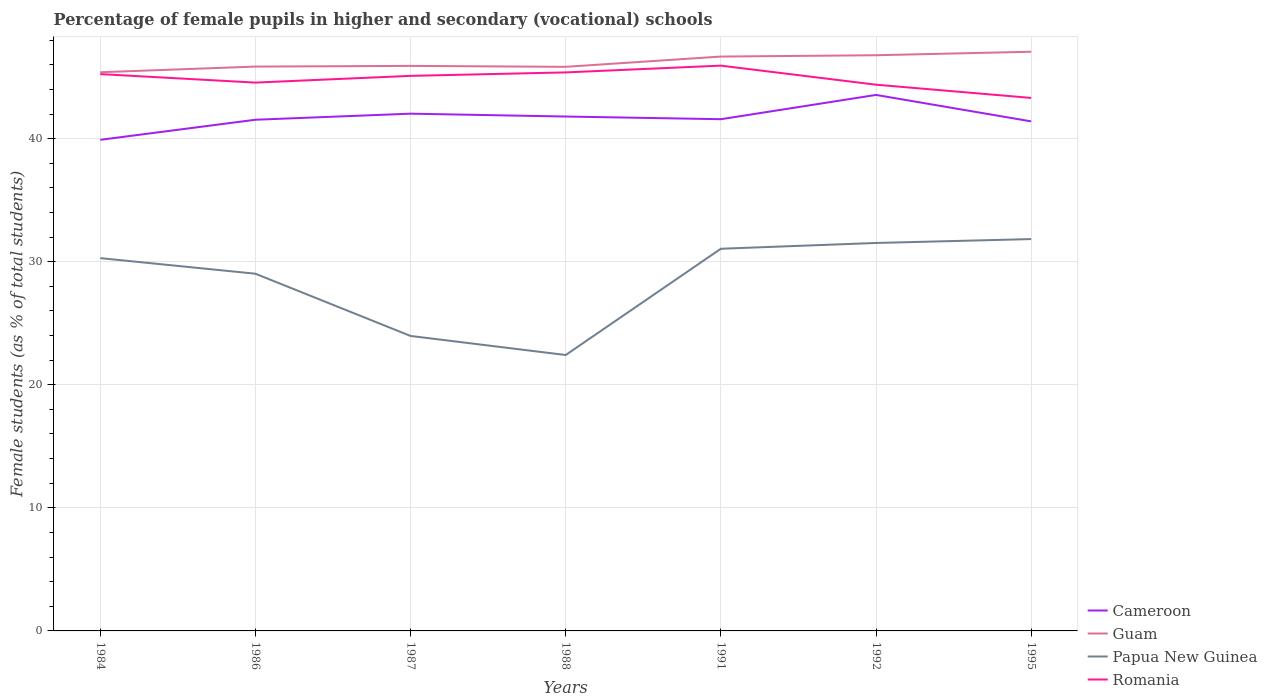Is the number of lines equal to the number of legend labels?
Provide a short and direct response. Yes. Across all years, what is the maximum percentage of female pupils in higher and secondary schools in Cameroon?
Ensure brevity in your answer.  39.9. In which year was the percentage of female pupils in higher and secondary schools in Guam maximum?
Your answer should be compact. 1984. What is the total percentage of female pupils in higher and secondary schools in Cameroon in the graph?
Make the answer very short. -1.67. What is the difference between the highest and the second highest percentage of female pupils in higher and secondary schools in Guam?
Your response must be concise. 1.67. What is the difference between the highest and the lowest percentage of female pupils in higher and secondary schools in Romania?
Keep it short and to the point. 4. Is the percentage of female pupils in higher and secondary schools in Romania strictly greater than the percentage of female pupils in higher and secondary schools in Guam over the years?
Offer a very short reply. Yes. What is the difference between two consecutive major ticks on the Y-axis?
Give a very brief answer. 10. Where does the legend appear in the graph?
Offer a very short reply. Bottom right. How many legend labels are there?
Keep it short and to the point. 4. How are the legend labels stacked?
Provide a succinct answer. Vertical. What is the title of the graph?
Keep it short and to the point. Percentage of female pupils in higher and secondary (vocational) schools. What is the label or title of the X-axis?
Make the answer very short. Years. What is the label or title of the Y-axis?
Make the answer very short. Female students (as % of total students). What is the Female students (as % of total students) of Cameroon in 1984?
Provide a succinct answer. 39.9. What is the Female students (as % of total students) in Guam in 1984?
Give a very brief answer. 45.39. What is the Female students (as % of total students) of Papua New Guinea in 1984?
Ensure brevity in your answer.  30.29. What is the Female students (as % of total students) of Romania in 1984?
Make the answer very short. 45.24. What is the Female students (as % of total students) of Cameroon in 1986?
Your response must be concise. 41.53. What is the Female students (as % of total students) in Guam in 1986?
Ensure brevity in your answer.  45.85. What is the Female students (as % of total students) in Papua New Guinea in 1986?
Offer a very short reply. 29.02. What is the Female students (as % of total students) in Romania in 1986?
Your response must be concise. 44.55. What is the Female students (as % of total students) in Cameroon in 1987?
Ensure brevity in your answer.  42.03. What is the Female students (as % of total students) in Guam in 1987?
Give a very brief answer. 45.91. What is the Female students (as % of total students) in Papua New Guinea in 1987?
Ensure brevity in your answer.  23.97. What is the Female students (as % of total students) of Romania in 1987?
Keep it short and to the point. 45.1. What is the Female students (as % of total students) in Cameroon in 1988?
Provide a succinct answer. 41.79. What is the Female students (as % of total students) in Guam in 1988?
Keep it short and to the point. 45.83. What is the Female students (as % of total students) of Papua New Guinea in 1988?
Offer a very short reply. 22.42. What is the Female students (as % of total students) in Romania in 1988?
Provide a short and direct response. 45.38. What is the Female students (as % of total students) of Cameroon in 1991?
Give a very brief answer. 41.58. What is the Female students (as % of total students) of Guam in 1991?
Keep it short and to the point. 46.67. What is the Female students (as % of total students) in Papua New Guinea in 1991?
Your answer should be very brief. 31.05. What is the Female students (as % of total students) in Romania in 1991?
Give a very brief answer. 45.93. What is the Female students (as % of total students) in Cameroon in 1992?
Offer a very short reply. 43.55. What is the Female students (as % of total students) in Guam in 1992?
Keep it short and to the point. 46.77. What is the Female students (as % of total students) in Papua New Guinea in 1992?
Give a very brief answer. 31.52. What is the Female students (as % of total students) of Romania in 1992?
Your answer should be very brief. 44.38. What is the Female students (as % of total students) in Cameroon in 1995?
Provide a succinct answer. 41.4. What is the Female students (as % of total students) of Guam in 1995?
Offer a terse response. 47.06. What is the Female students (as % of total students) of Papua New Guinea in 1995?
Offer a terse response. 31.84. What is the Female students (as % of total students) of Romania in 1995?
Offer a terse response. 43.31. Across all years, what is the maximum Female students (as % of total students) in Cameroon?
Your response must be concise. 43.55. Across all years, what is the maximum Female students (as % of total students) of Guam?
Offer a terse response. 47.06. Across all years, what is the maximum Female students (as % of total students) in Papua New Guinea?
Provide a succinct answer. 31.84. Across all years, what is the maximum Female students (as % of total students) of Romania?
Ensure brevity in your answer.  45.93. Across all years, what is the minimum Female students (as % of total students) of Cameroon?
Offer a terse response. 39.9. Across all years, what is the minimum Female students (as % of total students) in Guam?
Provide a succinct answer. 45.39. Across all years, what is the minimum Female students (as % of total students) of Papua New Guinea?
Your answer should be compact. 22.42. Across all years, what is the minimum Female students (as % of total students) in Romania?
Give a very brief answer. 43.31. What is the total Female students (as % of total students) in Cameroon in the graph?
Provide a short and direct response. 291.79. What is the total Female students (as % of total students) of Guam in the graph?
Provide a short and direct response. 323.49. What is the total Female students (as % of total students) in Papua New Guinea in the graph?
Offer a very short reply. 200.11. What is the total Female students (as % of total students) of Romania in the graph?
Keep it short and to the point. 313.89. What is the difference between the Female students (as % of total students) of Cameroon in 1984 and that in 1986?
Ensure brevity in your answer.  -1.63. What is the difference between the Female students (as % of total students) of Guam in 1984 and that in 1986?
Give a very brief answer. -0.46. What is the difference between the Female students (as % of total students) of Papua New Guinea in 1984 and that in 1986?
Provide a succinct answer. 1.27. What is the difference between the Female students (as % of total students) of Romania in 1984 and that in 1986?
Provide a succinct answer. 0.69. What is the difference between the Female students (as % of total students) of Cameroon in 1984 and that in 1987?
Your response must be concise. -2.12. What is the difference between the Female students (as % of total students) of Guam in 1984 and that in 1987?
Provide a short and direct response. -0.52. What is the difference between the Female students (as % of total students) of Papua New Guinea in 1984 and that in 1987?
Provide a short and direct response. 6.32. What is the difference between the Female students (as % of total students) in Romania in 1984 and that in 1987?
Ensure brevity in your answer.  0.14. What is the difference between the Female students (as % of total students) in Cameroon in 1984 and that in 1988?
Make the answer very short. -1.89. What is the difference between the Female students (as % of total students) of Guam in 1984 and that in 1988?
Give a very brief answer. -0.44. What is the difference between the Female students (as % of total students) of Papua New Guinea in 1984 and that in 1988?
Your answer should be compact. 7.87. What is the difference between the Female students (as % of total students) in Romania in 1984 and that in 1988?
Make the answer very short. -0.14. What is the difference between the Female students (as % of total students) of Cameroon in 1984 and that in 1991?
Your answer should be compact. -1.67. What is the difference between the Female students (as % of total students) of Guam in 1984 and that in 1991?
Offer a very short reply. -1.27. What is the difference between the Female students (as % of total students) in Papua New Guinea in 1984 and that in 1991?
Give a very brief answer. -0.76. What is the difference between the Female students (as % of total students) of Romania in 1984 and that in 1991?
Provide a short and direct response. -0.69. What is the difference between the Female students (as % of total students) of Cameroon in 1984 and that in 1992?
Ensure brevity in your answer.  -3.65. What is the difference between the Female students (as % of total students) of Guam in 1984 and that in 1992?
Offer a very short reply. -1.38. What is the difference between the Female students (as % of total students) of Papua New Guinea in 1984 and that in 1992?
Keep it short and to the point. -1.23. What is the difference between the Female students (as % of total students) in Romania in 1984 and that in 1992?
Your answer should be compact. 0.86. What is the difference between the Female students (as % of total students) of Cameroon in 1984 and that in 1995?
Provide a short and direct response. -1.5. What is the difference between the Female students (as % of total students) in Guam in 1984 and that in 1995?
Give a very brief answer. -1.67. What is the difference between the Female students (as % of total students) in Papua New Guinea in 1984 and that in 1995?
Give a very brief answer. -1.55. What is the difference between the Female students (as % of total students) in Romania in 1984 and that in 1995?
Provide a succinct answer. 1.94. What is the difference between the Female students (as % of total students) of Cameroon in 1986 and that in 1987?
Provide a short and direct response. -0.49. What is the difference between the Female students (as % of total students) of Guam in 1986 and that in 1987?
Your response must be concise. -0.06. What is the difference between the Female students (as % of total students) in Papua New Guinea in 1986 and that in 1987?
Your answer should be very brief. 5.06. What is the difference between the Female students (as % of total students) of Romania in 1986 and that in 1987?
Make the answer very short. -0.55. What is the difference between the Female students (as % of total students) of Cameroon in 1986 and that in 1988?
Make the answer very short. -0.26. What is the difference between the Female students (as % of total students) of Guam in 1986 and that in 1988?
Provide a short and direct response. 0.02. What is the difference between the Female students (as % of total students) in Papua New Guinea in 1986 and that in 1988?
Your answer should be very brief. 6.6. What is the difference between the Female students (as % of total students) in Romania in 1986 and that in 1988?
Your answer should be compact. -0.83. What is the difference between the Female students (as % of total students) in Cameroon in 1986 and that in 1991?
Keep it short and to the point. -0.04. What is the difference between the Female students (as % of total students) of Guam in 1986 and that in 1991?
Make the answer very short. -0.81. What is the difference between the Female students (as % of total students) in Papua New Guinea in 1986 and that in 1991?
Ensure brevity in your answer.  -2.03. What is the difference between the Female students (as % of total students) in Romania in 1986 and that in 1991?
Offer a terse response. -1.38. What is the difference between the Female students (as % of total students) in Cameroon in 1986 and that in 1992?
Make the answer very short. -2.02. What is the difference between the Female students (as % of total students) in Guam in 1986 and that in 1992?
Your response must be concise. -0.92. What is the difference between the Female students (as % of total students) of Papua New Guinea in 1986 and that in 1992?
Provide a succinct answer. -2.5. What is the difference between the Female students (as % of total students) in Romania in 1986 and that in 1992?
Your answer should be compact. 0.17. What is the difference between the Female students (as % of total students) in Cameroon in 1986 and that in 1995?
Ensure brevity in your answer.  0.13. What is the difference between the Female students (as % of total students) in Guam in 1986 and that in 1995?
Provide a short and direct response. -1.21. What is the difference between the Female students (as % of total students) of Papua New Guinea in 1986 and that in 1995?
Give a very brief answer. -2.81. What is the difference between the Female students (as % of total students) in Romania in 1986 and that in 1995?
Offer a very short reply. 1.25. What is the difference between the Female students (as % of total students) of Cameroon in 1987 and that in 1988?
Provide a succinct answer. 0.23. What is the difference between the Female students (as % of total students) in Guam in 1987 and that in 1988?
Keep it short and to the point. 0.08. What is the difference between the Female students (as % of total students) of Papua New Guinea in 1987 and that in 1988?
Ensure brevity in your answer.  1.55. What is the difference between the Female students (as % of total students) in Romania in 1987 and that in 1988?
Provide a short and direct response. -0.28. What is the difference between the Female students (as % of total students) in Cameroon in 1987 and that in 1991?
Provide a succinct answer. 0.45. What is the difference between the Female students (as % of total students) of Guam in 1987 and that in 1991?
Offer a terse response. -0.76. What is the difference between the Female students (as % of total students) in Papua New Guinea in 1987 and that in 1991?
Provide a succinct answer. -7.09. What is the difference between the Female students (as % of total students) in Romania in 1987 and that in 1991?
Make the answer very short. -0.83. What is the difference between the Female students (as % of total students) in Cameroon in 1987 and that in 1992?
Offer a terse response. -1.52. What is the difference between the Female students (as % of total students) in Guam in 1987 and that in 1992?
Your answer should be compact. -0.87. What is the difference between the Female students (as % of total students) of Papua New Guinea in 1987 and that in 1992?
Make the answer very short. -7.56. What is the difference between the Female students (as % of total students) in Romania in 1987 and that in 1992?
Offer a very short reply. 0.72. What is the difference between the Female students (as % of total students) in Cameroon in 1987 and that in 1995?
Provide a succinct answer. 0.63. What is the difference between the Female students (as % of total students) in Guam in 1987 and that in 1995?
Your answer should be compact. -1.15. What is the difference between the Female students (as % of total students) of Papua New Guinea in 1987 and that in 1995?
Offer a terse response. -7.87. What is the difference between the Female students (as % of total students) in Romania in 1987 and that in 1995?
Give a very brief answer. 1.79. What is the difference between the Female students (as % of total students) of Cameroon in 1988 and that in 1991?
Provide a succinct answer. 0.22. What is the difference between the Female students (as % of total students) of Papua New Guinea in 1988 and that in 1991?
Your answer should be compact. -8.63. What is the difference between the Female students (as % of total students) in Romania in 1988 and that in 1991?
Provide a succinct answer. -0.55. What is the difference between the Female students (as % of total students) of Cameroon in 1988 and that in 1992?
Keep it short and to the point. -1.76. What is the difference between the Female students (as % of total students) in Guam in 1988 and that in 1992?
Provide a succinct answer. -0.94. What is the difference between the Female students (as % of total students) of Papua New Guinea in 1988 and that in 1992?
Make the answer very short. -9.1. What is the difference between the Female students (as % of total students) in Romania in 1988 and that in 1992?
Provide a short and direct response. 1. What is the difference between the Female students (as % of total students) in Cameroon in 1988 and that in 1995?
Provide a succinct answer. 0.39. What is the difference between the Female students (as % of total students) of Guam in 1988 and that in 1995?
Provide a succinct answer. -1.23. What is the difference between the Female students (as % of total students) in Papua New Guinea in 1988 and that in 1995?
Ensure brevity in your answer.  -9.42. What is the difference between the Female students (as % of total students) of Romania in 1988 and that in 1995?
Your answer should be very brief. 2.07. What is the difference between the Female students (as % of total students) in Cameroon in 1991 and that in 1992?
Provide a succinct answer. -1.97. What is the difference between the Female students (as % of total students) of Guam in 1991 and that in 1992?
Offer a terse response. -0.11. What is the difference between the Female students (as % of total students) of Papua New Guinea in 1991 and that in 1992?
Offer a terse response. -0.47. What is the difference between the Female students (as % of total students) in Romania in 1991 and that in 1992?
Your answer should be compact. 1.55. What is the difference between the Female students (as % of total students) of Cameroon in 1991 and that in 1995?
Offer a terse response. 0.18. What is the difference between the Female students (as % of total students) in Guam in 1991 and that in 1995?
Your response must be concise. -0.39. What is the difference between the Female students (as % of total students) in Papua New Guinea in 1991 and that in 1995?
Offer a very short reply. -0.79. What is the difference between the Female students (as % of total students) in Romania in 1991 and that in 1995?
Keep it short and to the point. 2.62. What is the difference between the Female students (as % of total students) in Cameroon in 1992 and that in 1995?
Offer a very short reply. 2.15. What is the difference between the Female students (as % of total students) in Guam in 1992 and that in 1995?
Give a very brief answer. -0.28. What is the difference between the Female students (as % of total students) in Papua New Guinea in 1992 and that in 1995?
Ensure brevity in your answer.  -0.32. What is the difference between the Female students (as % of total students) in Romania in 1992 and that in 1995?
Give a very brief answer. 1.08. What is the difference between the Female students (as % of total students) in Cameroon in 1984 and the Female students (as % of total students) in Guam in 1986?
Ensure brevity in your answer.  -5.95. What is the difference between the Female students (as % of total students) of Cameroon in 1984 and the Female students (as % of total students) of Papua New Guinea in 1986?
Provide a short and direct response. 10.88. What is the difference between the Female students (as % of total students) of Cameroon in 1984 and the Female students (as % of total students) of Romania in 1986?
Offer a very short reply. -4.65. What is the difference between the Female students (as % of total students) of Guam in 1984 and the Female students (as % of total students) of Papua New Guinea in 1986?
Make the answer very short. 16.37. What is the difference between the Female students (as % of total students) of Guam in 1984 and the Female students (as % of total students) of Romania in 1986?
Offer a terse response. 0.84. What is the difference between the Female students (as % of total students) in Papua New Guinea in 1984 and the Female students (as % of total students) in Romania in 1986?
Offer a very short reply. -14.26. What is the difference between the Female students (as % of total students) of Cameroon in 1984 and the Female students (as % of total students) of Guam in 1987?
Your answer should be very brief. -6.01. What is the difference between the Female students (as % of total students) of Cameroon in 1984 and the Female students (as % of total students) of Papua New Guinea in 1987?
Offer a terse response. 15.94. What is the difference between the Female students (as % of total students) of Cameroon in 1984 and the Female students (as % of total students) of Romania in 1987?
Ensure brevity in your answer.  -5.2. What is the difference between the Female students (as % of total students) in Guam in 1984 and the Female students (as % of total students) in Papua New Guinea in 1987?
Your answer should be compact. 21.43. What is the difference between the Female students (as % of total students) of Guam in 1984 and the Female students (as % of total students) of Romania in 1987?
Ensure brevity in your answer.  0.29. What is the difference between the Female students (as % of total students) in Papua New Guinea in 1984 and the Female students (as % of total students) in Romania in 1987?
Make the answer very short. -14.81. What is the difference between the Female students (as % of total students) in Cameroon in 1984 and the Female students (as % of total students) in Guam in 1988?
Ensure brevity in your answer.  -5.93. What is the difference between the Female students (as % of total students) of Cameroon in 1984 and the Female students (as % of total students) of Papua New Guinea in 1988?
Keep it short and to the point. 17.48. What is the difference between the Female students (as % of total students) of Cameroon in 1984 and the Female students (as % of total students) of Romania in 1988?
Make the answer very short. -5.48. What is the difference between the Female students (as % of total students) of Guam in 1984 and the Female students (as % of total students) of Papua New Guinea in 1988?
Your response must be concise. 22.97. What is the difference between the Female students (as % of total students) in Guam in 1984 and the Female students (as % of total students) in Romania in 1988?
Keep it short and to the point. 0.01. What is the difference between the Female students (as % of total students) of Papua New Guinea in 1984 and the Female students (as % of total students) of Romania in 1988?
Offer a terse response. -15.09. What is the difference between the Female students (as % of total students) of Cameroon in 1984 and the Female students (as % of total students) of Guam in 1991?
Offer a very short reply. -6.76. What is the difference between the Female students (as % of total students) of Cameroon in 1984 and the Female students (as % of total students) of Papua New Guinea in 1991?
Make the answer very short. 8.85. What is the difference between the Female students (as % of total students) of Cameroon in 1984 and the Female students (as % of total students) of Romania in 1991?
Give a very brief answer. -6.03. What is the difference between the Female students (as % of total students) of Guam in 1984 and the Female students (as % of total students) of Papua New Guinea in 1991?
Your answer should be compact. 14.34. What is the difference between the Female students (as % of total students) of Guam in 1984 and the Female students (as % of total students) of Romania in 1991?
Your answer should be compact. -0.54. What is the difference between the Female students (as % of total students) in Papua New Guinea in 1984 and the Female students (as % of total students) in Romania in 1991?
Make the answer very short. -15.64. What is the difference between the Female students (as % of total students) of Cameroon in 1984 and the Female students (as % of total students) of Guam in 1992?
Your answer should be very brief. -6.87. What is the difference between the Female students (as % of total students) of Cameroon in 1984 and the Female students (as % of total students) of Papua New Guinea in 1992?
Offer a very short reply. 8.38. What is the difference between the Female students (as % of total students) in Cameroon in 1984 and the Female students (as % of total students) in Romania in 1992?
Ensure brevity in your answer.  -4.48. What is the difference between the Female students (as % of total students) of Guam in 1984 and the Female students (as % of total students) of Papua New Guinea in 1992?
Give a very brief answer. 13.87. What is the difference between the Female students (as % of total students) of Guam in 1984 and the Female students (as % of total students) of Romania in 1992?
Your response must be concise. 1.01. What is the difference between the Female students (as % of total students) of Papua New Guinea in 1984 and the Female students (as % of total students) of Romania in 1992?
Your answer should be very brief. -14.09. What is the difference between the Female students (as % of total students) in Cameroon in 1984 and the Female students (as % of total students) in Guam in 1995?
Ensure brevity in your answer.  -7.16. What is the difference between the Female students (as % of total students) of Cameroon in 1984 and the Female students (as % of total students) of Papua New Guinea in 1995?
Your answer should be compact. 8.06. What is the difference between the Female students (as % of total students) of Cameroon in 1984 and the Female students (as % of total students) of Romania in 1995?
Keep it short and to the point. -3.4. What is the difference between the Female students (as % of total students) of Guam in 1984 and the Female students (as % of total students) of Papua New Guinea in 1995?
Provide a short and direct response. 13.55. What is the difference between the Female students (as % of total students) in Guam in 1984 and the Female students (as % of total students) in Romania in 1995?
Ensure brevity in your answer.  2.09. What is the difference between the Female students (as % of total students) in Papua New Guinea in 1984 and the Female students (as % of total students) in Romania in 1995?
Provide a succinct answer. -13.02. What is the difference between the Female students (as % of total students) in Cameroon in 1986 and the Female students (as % of total students) in Guam in 1987?
Your response must be concise. -4.38. What is the difference between the Female students (as % of total students) in Cameroon in 1986 and the Female students (as % of total students) in Papua New Guinea in 1987?
Your answer should be very brief. 17.57. What is the difference between the Female students (as % of total students) of Cameroon in 1986 and the Female students (as % of total students) of Romania in 1987?
Keep it short and to the point. -3.57. What is the difference between the Female students (as % of total students) in Guam in 1986 and the Female students (as % of total students) in Papua New Guinea in 1987?
Provide a succinct answer. 21.89. What is the difference between the Female students (as % of total students) in Guam in 1986 and the Female students (as % of total students) in Romania in 1987?
Give a very brief answer. 0.76. What is the difference between the Female students (as % of total students) in Papua New Guinea in 1986 and the Female students (as % of total students) in Romania in 1987?
Provide a short and direct response. -16.08. What is the difference between the Female students (as % of total students) of Cameroon in 1986 and the Female students (as % of total students) of Guam in 1988?
Offer a terse response. -4.3. What is the difference between the Female students (as % of total students) in Cameroon in 1986 and the Female students (as % of total students) in Papua New Guinea in 1988?
Your answer should be very brief. 19.12. What is the difference between the Female students (as % of total students) of Cameroon in 1986 and the Female students (as % of total students) of Romania in 1988?
Give a very brief answer. -3.85. What is the difference between the Female students (as % of total students) of Guam in 1986 and the Female students (as % of total students) of Papua New Guinea in 1988?
Keep it short and to the point. 23.44. What is the difference between the Female students (as % of total students) in Guam in 1986 and the Female students (as % of total students) in Romania in 1988?
Make the answer very short. 0.47. What is the difference between the Female students (as % of total students) in Papua New Guinea in 1986 and the Female students (as % of total students) in Romania in 1988?
Your answer should be very brief. -16.36. What is the difference between the Female students (as % of total students) in Cameroon in 1986 and the Female students (as % of total students) in Guam in 1991?
Give a very brief answer. -5.13. What is the difference between the Female students (as % of total students) in Cameroon in 1986 and the Female students (as % of total students) in Papua New Guinea in 1991?
Provide a short and direct response. 10.48. What is the difference between the Female students (as % of total students) in Cameroon in 1986 and the Female students (as % of total students) in Romania in 1991?
Make the answer very short. -4.4. What is the difference between the Female students (as % of total students) in Guam in 1986 and the Female students (as % of total students) in Papua New Guinea in 1991?
Offer a very short reply. 14.8. What is the difference between the Female students (as % of total students) in Guam in 1986 and the Female students (as % of total students) in Romania in 1991?
Offer a terse response. -0.08. What is the difference between the Female students (as % of total students) in Papua New Guinea in 1986 and the Female students (as % of total students) in Romania in 1991?
Your answer should be compact. -16.91. What is the difference between the Female students (as % of total students) of Cameroon in 1986 and the Female students (as % of total students) of Guam in 1992?
Offer a terse response. -5.24. What is the difference between the Female students (as % of total students) of Cameroon in 1986 and the Female students (as % of total students) of Papua New Guinea in 1992?
Provide a short and direct response. 10.01. What is the difference between the Female students (as % of total students) in Cameroon in 1986 and the Female students (as % of total students) in Romania in 1992?
Ensure brevity in your answer.  -2.85. What is the difference between the Female students (as % of total students) in Guam in 1986 and the Female students (as % of total students) in Papua New Guinea in 1992?
Offer a terse response. 14.33. What is the difference between the Female students (as % of total students) of Guam in 1986 and the Female students (as % of total students) of Romania in 1992?
Keep it short and to the point. 1.47. What is the difference between the Female students (as % of total students) in Papua New Guinea in 1986 and the Female students (as % of total students) in Romania in 1992?
Your response must be concise. -15.36. What is the difference between the Female students (as % of total students) of Cameroon in 1986 and the Female students (as % of total students) of Guam in 1995?
Ensure brevity in your answer.  -5.53. What is the difference between the Female students (as % of total students) in Cameroon in 1986 and the Female students (as % of total students) in Papua New Guinea in 1995?
Your response must be concise. 9.7. What is the difference between the Female students (as % of total students) in Cameroon in 1986 and the Female students (as % of total students) in Romania in 1995?
Ensure brevity in your answer.  -1.77. What is the difference between the Female students (as % of total students) of Guam in 1986 and the Female students (as % of total students) of Papua New Guinea in 1995?
Provide a short and direct response. 14.02. What is the difference between the Female students (as % of total students) of Guam in 1986 and the Female students (as % of total students) of Romania in 1995?
Your answer should be compact. 2.55. What is the difference between the Female students (as % of total students) of Papua New Guinea in 1986 and the Female students (as % of total students) of Romania in 1995?
Give a very brief answer. -14.28. What is the difference between the Female students (as % of total students) in Cameroon in 1987 and the Female students (as % of total students) in Guam in 1988?
Offer a very short reply. -3.81. What is the difference between the Female students (as % of total students) of Cameroon in 1987 and the Female students (as % of total students) of Papua New Guinea in 1988?
Offer a very short reply. 19.61. What is the difference between the Female students (as % of total students) of Cameroon in 1987 and the Female students (as % of total students) of Romania in 1988?
Your answer should be very brief. -3.35. What is the difference between the Female students (as % of total students) in Guam in 1987 and the Female students (as % of total students) in Papua New Guinea in 1988?
Provide a succinct answer. 23.49. What is the difference between the Female students (as % of total students) in Guam in 1987 and the Female students (as % of total students) in Romania in 1988?
Your answer should be very brief. 0.53. What is the difference between the Female students (as % of total students) in Papua New Guinea in 1987 and the Female students (as % of total students) in Romania in 1988?
Offer a very short reply. -21.41. What is the difference between the Female students (as % of total students) in Cameroon in 1987 and the Female students (as % of total students) in Guam in 1991?
Keep it short and to the point. -4.64. What is the difference between the Female students (as % of total students) in Cameroon in 1987 and the Female students (as % of total students) in Papua New Guinea in 1991?
Offer a terse response. 10.97. What is the difference between the Female students (as % of total students) in Cameroon in 1987 and the Female students (as % of total students) in Romania in 1991?
Provide a short and direct response. -3.9. What is the difference between the Female students (as % of total students) in Guam in 1987 and the Female students (as % of total students) in Papua New Guinea in 1991?
Ensure brevity in your answer.  14.86. What is the difference between the Female students (as % of total students) of Guam in 1987 and the Female students (as % of total students) of Romania in 1991?
Offer a terse response. -0.02. What is the difference between the Female students (as % of total students) of Papua New Guinea in 1987 and the Female students (as % of total students) of Romania in 1991?
Ensure brevity in your answer.  -21.96. What is the difference between the Female students (as % of total students) in Cameroon in 1987 and the Female students (as % of total students) in Guam in 1992?
Make the answer very short. -4.75. What is the difference between the Female students (as % of total students) of Cameroon in 1987 and the Female students (as % of total students) of Papua New Guinea in 1992?
Provide a succinct answer. 10.51. What is the difference between the Female students (as % of total students) in Cameroon in 1987 and the Female students (as % of total students) in Romania in 1992?
Ensure brevity in your answer.  -2.35. What is the difference between the Female students (as % of total students) of Guam in 1987 and the Female students (as % of total students) of Papua New Guinea in 1992?
Your answer should be very brief. 14.39. What is the difference between the Female students (as % of total students) of Guam in 1987 and the Female students (as % of total students) of Romania in 1992?
Offer a terse response. 1.53. What is the difference between the Female students (as % of total students) of Papua New Guinea in 1987 and the Female students (as % of total students) of Romania in 1992?
Ensure brevity in your answer.  -20.42. What is the difference between the Female students (as % of total students) of Cameroon in 1987 and the Female students (as % of total students) of Guam in 1995?
Your answer should be compact. -5.03. What is the difference between the Female students (as % of total students) of Cameroon in 1987 and the Female students (as % of total students) of Papua New Guinea in 1995?
Keep it short and to the point. 10.19. What is the difference between the Female students (as % of total students) of Cameroon in 1987 and the Female students (as % of total students) of Romania in 1995?
Offer a terse response. -1.28. What is the difference between the Female students (as % of total students) in Guam in 1987 and the Female students (as % of total students) in Papua New Guinea in 1995?
Give a very brief answer. 14.07. What is the difference between the Female students (as % of total students) of Guam in 1987 and the Female students (as % of total students) of Romania in 1995?
Your response must be concise. 2.6. What is the difference between the Female students (as % of total students) of Papua New Guinea in 1987 and the Female students (as % of total students) of Romania in 1995?
Your response must be concise. -19.34. What is the difference between the Female students (as % of total students) of Cameroon in 1988 and the Female students (as % of total students) of Guam in 1991?
Provide a short and direct response. -4.87. What is the difference between the Female students (as % of total students) in Cameroon in 1988 and the Female students (as % of total students) in Papua New Guinea in 1991?
Ensure brevity in your answer.  10.74. What is the difference between the Female students (as % of total students) in Cameroon in 1988 and the Female students (as % of total students) in Romania in 1991?
Your answer should be compact. -4.14. What is the difference between the Female students (as % of total students) in Guam in 1988 and the Female students (as % of total students) in Papua New Guinea in 1991?
Provide a succinct answer. 14.78. What is the difference between the Female students (as % of total students) in Guam in 1988 and the Female students (as % of total students) in Romania in 1991?
Offer a terse response. -0.1. What is the difference between the Female students (as % of total students) in Papua New Guinea in 1988 and the Female students (as % of total students) in Romania in 1991?
Keep it short and to the point. -23.51. What is the difference between the Female students (as % of total students) in Cameroon in 1988 and the Female students (as % of total students) in Guam in 1992?
Give a very brief answer. -4.98. What is the difference between the Female students (as % of total students) in Cameroon in 1988 and the Female students (as % of total students) in Papua New Guinea in 1992?
Offer a very short reply. 10.27. What is the difference between the Female students (as % of total students) of Cameroon in 1988 and the Female students (as % of total students) of Romania in 1992?
Provide a succinct answer. -2.59. What is the difference between the Female students (as % of total students) in Guam in 1988 and the Female students (as % of total students) in Papua New Guinea in 1992?
Your response must be concise. 14.31. What is the difference between the Female students (as % of total students) of Guam in 1988 and the Female students (as % of total students) of Romania in 1992?
Ensure brevity in your answer.  1.45. What is the difference between the Female students (as % of total students) in Papua New Guinea in 1988 and the Female students (as % of total students) in Romania in 1992?
Make the answer very short. -21.96. What is the difference between the Female students (as % of total students) of Cameroon in 1988 and the Female students (as % of total students) of Guam in 1995?
Your answer should be compact. -5.26. What is the difference between the Female students (as % of total students) in Cameroon in 1988 and the Female students (as % of total students) in Papua New Guinea in 1995?
Provide a succinct answer. 9.96. What is the difference between the Female students (as % of total students) of Cameroon in 1988 and the Female students (as % of total students) of Romania in 1995?
Ensure brevity in your answer.  -1.51. What is the difference between the Female students (as % of total students) in Guam in 1988 and the Female students (as % of total students) in Papua New Guinea in 1995?
Offer a very short reply. 14. What is the difference between the Female students (as % of total students) of Guam in 1988 and the Female students (as % of total students) of Romania in 1995?
Provide a short and direct response. 2.53. What is the difference between the Female students (as % of total students) in Papua New Guinea in 1988 and the Female students (as % of total students) in Romania in 1995?
Offer a very short reply. -20.89. What is the difference between the Female students (as % of total students) in Cameroon in 1991 and the Female students (as % of total students) in Guam in 1992?
Your response must be concise. -5.2. What is the difference between the Female students (as % of total students) of Cameroon in 1991 and the Female students (as % of total students) of Papua New Guinea in 1992?
Your answer should be very brief. 10.06. What is the difference between the Female students (as % of total students) in Cameroon in 1991 and the Female students (as % of total students) in Romania in 1992?
Provide a succinct answer. -2.8. What is the difference between the Female students (as % of total students) in Guam in 1991 and the Female students (as % of total students) in Papua New Guinea in 1992?
Ensure brevity in your answer.  15.15. What is the difference between the Female students (as % of total students) in Guam in 1991 and the Female students (as % of total students) in Romania in 1992?
Provide a short and direct response. 2.29. What is the difference between the Female students (as % of total students) of Papua New Guinea in 1991 and the Female students (as % of total students) of Romania in 1992?
Keep it short and to the point. -13.33. What is the difference between the Female students (as % of total students) of Cameroon in 1991 and the Female students (as % of total students) of Guam in 1995?
Ensure brevity in your answer.  -5.48. What is the difference between the Female students (as % of total students) in Cameroon in 1991 and the Female students (as % of total students) in Papua New Guinea in 1995?
Your answer should be compact. 9.74. What is the difference between the Female students (as % of total students) in Cameroon in 1991 and the Female students (as % of total students) in Romania in 1995?
Provide a short and direct response. -1.73. What is the difference between the Female students (as % of total students) in Guam in 1991 and the Female students (as % of total students) in Papua New Guinea in 1995?
Keep it short and to the point. 14.83. What is the difference between the Female students (as % of total students) in Guam in 1991 and the Female students (as % of total students) in Romania in 1995?
Your answer should be compact. 3.36. What is the difference between the Female students (as % of total students) in Papua New Guinea in 1991 and the Female students (as % of total students) in Romania in 1995?
Provide a succinct answer. -12.25. What is the difference between the Female students (as % of total students) in Cameroon in 1992 and the Female students (as % of total students) in Guam in 1995?
Provide a short and direct response. -3.51. What is the difference between the Female students (as % of total students) in Cameroon in 1992 and the Female students (as % of total students) in Papua New Guinea in 1995?
Your answer should be compact. 11.71. What is the difference between the Female students (as % of total students) of Cameroon in 1992 and the Female students (as % of total students) of Romania in 1995?
Provide a short and direct response. 0.24. What is the difference between the Female students (as % of total students) of Guam in 1992 and the Female students (as % of total students) of Papua New Guinea in 1995?
Give a very brief answer. 14.94. What is the difference between the Female students (as % of total students) of Guam in 1992 and the Female students (as % of total students) of Romania in 1995?
Keep it short and to the point. 3.47. What is the difference between the Female students (as % of total students) of Papua New Guinea in 1992 and the Female students (as % of total students) of Romania in 1995?
Your response must be concise. -11.78. What is the average Female students (as % of total students) of Cameroon per year?
Keep it short and to the point. 41.68. What is the average Female students (as % of total students) of Guam per year?
Your answer should be very brief. 46.21. What is the average Female students (as % of total students) in Papua New Guinea per year?
Ensure brevity in your answer.  28.59. What is the average Female students (as % of total students) of Romania per year?
Make the answer very short. 44.84. In the year 1984, what is the difference between the Female students (as % of total students) of Cameroon and Female students (as % of total students) of Guam?
Offer a terse response. -5.49. In the year 1984, what is the difference between the Female students (as % of total students) in Cameroon and Female students (as % of total students) in Papua New Guinea?
Provide a short and direct response. 9.61. In the year 1984, what is the difference between the Female students (as % of total students) in Cameroon and Female students (as % of total students) in Romania?
Keep it short and to the point. -5.34. In the year 1984, what is the difference between the Female students (as % of total students) in Guam and Female students (as % of total students) in Papua New Guinea?
Give a very brief answer. 15.1. In the year 1984, what is the difference between the Female students (as % of total students) of Guam and Female students (as % of total students) of Romania?
Your answer should be very brief. 0.15. In the year 1984, what is the difference between the Female students (as % of total students) in Papua New Guinea and Female students (as % of total students) in Romania?
Keep it short and to the point. -14.95. In the year 1986, what is the difference between the Female students (as % of total students) of Cameroon and Female students (as % of total students) of Guam?
Ensure brevity in your answer.  -4.32. In the year 1986, what is the difference between the Female students (as % of total students) in Cameroon and Female students (as % of total students) in Papua New Guinea?
Your response must be concise. 12.51. In the year 1986, what is the difference between the Female students (as % of total students) of Cameroon and Female students (as % of total students) of Romania?
Your answer should be very brief. -3.02. In the year 1986, what is the difference between the Female students (as % of total students) of Guam and Female students (as % of total students) of Papua New Guinea?
Provide a short and direct response. 16.83. In the year 1986, what is the difference between the Female students (as % of total students) in Guam and Female students (as % of total students) in Romania?
Offer a very short reply. 1.3. In the year 1986, what is the difference between the Female students (as % of total students) in Papua New Guinea and Female students (as % of total students) in Romania?
Make the answer very short. -15.53. In the year 1987, what is the difference between the Female students (as % of total students) in Cameroon and Female students (as % of total students) in Guam?
Your answer should be very brief. -3.88. In the year 1987, what is the difference between the Female students (as % of total students) of Cameroon and Female students (as % of total students) of Papua New Guinea?
Give a very brief answer. 18.06. In the year 1987, what is the difference between the Female students (as % of total students) of Cameroon and Female students (as % of total students) of Romania?
Provide a short and direct response. -3.07. In the year 1987, what is the difference between the Female students (as % of total students) of Guam and Female students (as % of total students) of Papua New Guinea?
Give a very brief answer. 21.94. In the year 1987, what is the difference between the Female students (as % of total students) of Guam and Female students (as % of total students) of Romania?
Provide a succinct answer. 0.81. In the year 1987, what is the difference between the Female students (as % of total students) in Papua New Guinea and Female students (as % of total students) in Romania?
Keep it short and to the point. -21.13. In the year 1988, what is the difference between the Female students (as % of total students) in Cameroon and Female students (as % of total students) in Guam?
Provide a succinct answer. -4.04. In the year 1988, what is the difference between the Female students (as % of total students) in Cameroon and Female students (as % of total students) in Papua New Guinea?
Give a very brief answer. 19.38. In the year 1988, what is the difference between the Female students (as % of total students) in Cameroon and Female students (as % of total students) in Romania?
Provide a succinct answer. -3.58. In the year 1988, what is the difference between the Female students (as % of total students) of Guam and Female students (as % of total students) of Papua New Guinea?
Your response must be concise. 23.41. In the year 1988, what is the difference between the Female students (as % of total students) of Guam and Female students (as % of total students) of Romania?
Provide a succinct answer. 0.45. In the year 1988, what is the difference between the Female students (as % of total students) in Papua New Guinea and Female students (as % of total students) in Romania?
Your answer should be compact. -22.96. In the year 1991, what is the difference between the Female students (as % of total students) of Cameroon and Female students (as % of total students) of Guam?
Keep it short and to the point. -5.09. In the year 1991, what is the difference between the Female students (as % of total students) in Cameroon and Female students (as % of total students) in Papua New Guinea?
Offer a very short reply. 10.53. In the year 1991, what is the difference between the Female students (as % of total students) in Cameroon and Female students (as % of total students) in Romania?
Your answer should be compact. -4.35. In the year 1991, what is the difference between the Female students (as % of total students) in Guam and Female students (as % of total students) in Papua New Guinea?
Your answer should be compact. 15.61. In the year 1991, what is the difference between the Female students (as % of total students) in Guam and Female students (as % of total students) in Romania?
Your answer should be very brief. 0.74. In the year 1991, what is the difference between the Female students (as % of total students) of Papua New Guinea and Female students (as % of total students) of Romania?
Offer a very short reply. -14.88. In the year 1992, what is the difference between the Female students (as % of total students) in Cameroon and Female students (as % of total students) in Guam?
Keep it short and to the point. -3.22. In the year 1992, what is the difference between the Female students (as % of total students) of Cameroon and Female students (as % of total students) of Papua New Guinea?
Ensure brevity in your answer.  12.03. In the year 1992, what is the difference between the Female students (as % of total students) in Cameroon and Female students (as % of total students) in Romania?
Ensure brevity in your answer.  -0.83. In the year 1992, what is the difference between the Female students (as % of total students) of Guam and Female students (as % of total students) of Papua New Guinea?
Your answer should be very brief. 15.25. In the year 1992, what is the difference between the Female students (as % of total students) in Guam and Female students (as % of total students) in Romania?
Ensure brevity in your answer.  2.39. In the year 1992, what is the difference between the Female students (as % of total students) of Papua New Guinea and Female students (as % of total students) of Romania?
Your answer should be very brief. -12.86. In the year 1995, what is the difference between the Female students (as % of total students) of Cameroon and Female students (as % of total students) of Guam?
Offer a terse response. -5.66. In the year 1995, what is the difference between the Female students (as % of total students) in Cameroon and Female students (as % of total students) in Papua New Guinea?
Offer a very short reply. 9.56. In the year 1995, what is the difference between the Female students (as % of total students) in Cameroon and Female students (as % of total students) in Romania?
Offer a very short reply. -1.9. In the year 1995, what is the difference between the Female students (as % of total students) in Guam and Female students (as % of total students) in Papua New Guinea?
Give a very brief answer. 15.22. In the year 1995, what is the difference between the Female students (as % of total students) in Guam and Female students (as % of total students) in Romania?
Your response must be concise. 3.75. In the year 1995, what is the difference between the Female students (as % of total students) in Papua New Guinea and Female students (as % of total students) in Romania?
Keep it short and to the point. -11.47. What is the ratio of the Female students (as % of total students) of Cameroon in 1984 to that in 1986?
Provide a short and direct response. 0.96. What is the ratio of the Female students (as % of total students) in Guam in 1984 to that in 1986?
Your answer should be very brief. 0.99. What is the ratio of the Female students (as % of total students) in Papua New Guinea in 1984 to that in 1986?
Provide a succinct answer. 1.04. What is the ratio of the Female students (as % of total students) of Romania in 1984 to that in 1986?
Ensure brevity in your answer.  1.02. What is the ratio of the Female students (as % of total students) of Cameroon in 1984 to that in 1987?
Provide a short and direct response. 0.95. What is the ratio of the Female students (as % of total students) in Guam in 1984 to that in 1987?
Offer a very short reply. 0.99. What is the ratio of the Female students (as % of total students) in Papua New Guinea in 1984 to that in 1987?
Offer a terse response. 1.26. What is the ratio of the Female students (as % of total students) of Romania in 1984 to that in 1987?
Offer a terse response. 1. What is the ratio of the Female students (as % of total students) of Cameroon in 1984 to that in 1988?
Give a very brief answer. 0.95. What is the ratio of the Female students (as % of total students) of Guam in 1984 to that in 1988?
Ensure brevity in your answer.  0.99. What is the ratio of the Female students (as % of total students) of Papua New Guinea in 1984 to that in 1988?
Ensure brevity in your answer.  1.35. What is the ratio of the Female students (as % of total students) of Romania in 1984 to that in 1988?
Your response must be concise. 1. What is the ratio of the Female students (as % of total students) of Cameroon in 1984 to that in 1991?
Offer a very short reply. 0.96. What is the ratio of the Female students (as % of total students) in Guam in 1984 to that in 1991?
Your response must be concise. 0.97. What is the ratio of the Female students (as % of total students) in Papua New Guinea in 1984 to that in 1991?
Give a very brief answer. 0.98. What is the ratio of the Female students (as % of total students) in Cameroon in 1984 to that in 1992?
Your answer should be compact. 0.92. What is the ratio of the Female students (as % of total students) in Guam in 1984 to that in 1992?
Give a very brief answer. 0.97. What is the ratio of the Female students (as % of total students) in Papua New Guinea in 1984 to that in 1992?
Make the answer very short. 0.96. What is the ratio of the Female students (as % of total students) in Romania in 1984 to that in 1992?
Ensure brevity in your answer.  1.02. What is the ratio of the Female students (as % of total students) of Cameroon in 1984 to that in 1995?
Your response must be concise. 0.96. What is the ratio of the Female students (as % of total students) in Guam in 1984 to that in 1995?
Your response must be concise. 0.96. What is the ratio of the Female students (as % of total students) in Papua New Guinea in 1984 to that in 1995?
Your response must be concise. 0.95. What is the ratio of the Female students (as % of total students) of Romania in 1984 to that in 1995?
Keep it short and to the point. 1.04. What is the ratio of the Female students (as % of total students) in Cameroon in 1986 to that in 1987?
Provide a succinct answer. 0.99. What is the ratio of the Female students (as % of total students) in Guam in 1986 to that in 1987?
Your answer should be very brief. 1. What is the ratio of the Female students (as % of total students) of Papua New Guinea in 1986 to that in 1987?
Ensure brevity in your answer.  1.21. What is the ratio of the Female students (as % of total students) of Romania in 1986 to that in 1987?
Ensure brevity in your answer.  0.99. What is the ratio of the Female students (as % of total students) in Cameroon in 1986 to that in 1988?
Offer a terse response. 0.99. What is the ratio of the Female students (as % of total students) in Guam in 1986 to that in 1988?
Keep it short and to the point. 1. What is the ratio of the Female students (as % of total students) of Papua New Guinea in 1986 to that in 1988?
Offer a very short reply. 1.29. What is the ratio of the Female students (as % of total students) in Romania in 1986 to that in 1988?
Your answer should be very brief. 0.98. What is the ratio of the Female students (as % of total students) of Guam in 1986 to that in 1991?
Ensure brevity in your answer.  0.98. What is the ratio of the Female students (as % of total students) in Papua New Guinea in 1986 to that in 1991?
Your answer should be compact. 0.93. What is the ratio of the Female students (as % of total students) of Cameroon in 1986 to that in 1992?
Give a very brief answer. 0.95. What is the ratio of the Female students (as % of total students) in Guam in 1986 to that in 1992?
Provide a succinct answer. 0.98. What is the ratio of the Female students (as % of total students) of Papua New Guinea in 1986 to that in 1992?
Provide a short and direct response. 0.92. What is the ratio of the Female students (as % of total students) in Cameroon in 1986 to that in 1995?
Your answer should be compact. 1. What is the ratio of the Female students (as % of total students) in Guam in 1986 to that in 1995?
Keep it short and to the point. 0.97. What is the ratio of the Female students (as % of total students) in Papua New Guinea in 1986 to that in 1995?
Provide a short and direct response. 0.91. What is the ratio of the Female students (as % of total students) in Romania in 1986 to that in 1995?
Your answer should be very brief. 1.03. What is the ratio of the Female students (as % of total students) in Cameroon in 1987 to that in 1988?
Offer a terse response. 1.01. What is the ratio of the Female students (as % of total students) of Guam in 1987 to that in 1988?
Provide a succinct answer. 1. What is the ratio of the Female students (as % of total students) of Papua New Guinea in 1987 to that in 1988?
Give a very brief answer. 1.07. What is the ratio of the Female students (as % of total students) of Romania in 1987 to that in 1988?
Your answer should be compact. 0.99. What is the ratio of the Female students (as % of total students) in Cameroon in 1987 to that in 1991?
Keep it short and to the point. 1.01. What is the ratio of the Female students (as % of total students) in Guam in 1987 to that in 1991?
Offer a very short reply. 0.98. What is the ratio of the Female students (as % of total students) of Papua New Guinea in 1987 to that in 1991?
Give a very brief answer. 0.77. What is the ratio of the Female students (as % of total students) of Romania in 1987 to that in 1991?
Give a very brief answer. 0.98. What is the ratio of the Female students (as % of total students) of Guam in 1987 to that in 1992?
Your answer should be very brief. 0.98. What is the ratio of the Female students (as % of total students) of Papua New Guinea in 1987 to that in 1992?
Offer a very short reply. 0.76. What is the ratio of the Female students (as % of total students) in Romania in 1987 to that in 1992?
Provide a short and direct response. 1.02. What is the ratio of the Female students (as % of total students) of Cameroon in 1987 to that in 1995?
Ensure brevity in your answer.  1.02. What is the ratio of the Female students (as % of total students) of Guam in 1987 to that in 1995?
Ensure brevity in your answer.  0.98. What is the ratio of the Female students (as % of total students) of Papua New Guinea in 1987 to that in 1995?
Ensure brevity in your answer.  0.75. What is the ratio of the Female students (as % of total students) of Romania in 1987 to that in 1995?
Offer a terse response. 1.04. What is the ratio of the Female students (as % of total students) of Guam in 1988 to that in 1991?
Offer a terse response. 0.98. What is the ratio of the Female students (as % of total students) in Papua New Guinea in 1988 to that in 1991?
Offer a very short reply. 0.72. What is the ratio of the Female students (as % of total students) of Cameroon in 1988 to that in 1992?
Make the answer very short. 0.96. What is the ratio of the Female students (as % of total students) of Guam in 1988 to that in 1992?
Your answer should be very brief. 0.98. What is the ratio of the Female students (as % of total students) of Papua New Guinea in 1988 to that in 1992?
Your answer should be very brief. 0.71. What is the ratio of the Female students (as % of total students) in Romania in 1988 to that in 1992?
Keep it short and to the point. 1.02. What is the ratio of the Female students (as % of total students) in Cameroon in 1988 to that in 1995?
Offer a terse response. 1.01. What is the ratio of the Female students (as % of total students) of Papua New Guinea in 1988 to that in 1995?
Your answer should be very brief. 0.7. What is the ratio of the Female students (as % of total students) in Romania in 1988 to that in 1995?
Give a very brief answer. 1.05. What is the ratio of the Female students (as % of total students) in Cameroon in 1991 to that in 1992?
Offer a very short reply. 0.95. What is the ratio of the Female students (as % of total students) in Papua New Guinea in 1991 to that in 1992?
Offer a very short reply. 0.99. What is the ratio of the Female students (as % of total students) in Romania in 1991 to that in 1992?
Your response must be concise. 1.03. What is the ratio of the Female students (as % of total students) of Cameroon in 1991 to that in 1995?
Provide a succinct answer. 1. What is the ratio of the Female students (as % of total students) of Guam in 1991 to that in 1995?
Offer a terse response. 0.99. What is the ratio of the Female students (as % of total students) in Papua New Guinea in 1991 to that in 1995?
Offer a very short reply. 0.98. What is the ratio of the Female students (as % of total students) in Romania in 1991 to that in 1995?
Provide a succinct answer. 1.06. What is the ratio of the Female students (as % of total students) in Cameroon in 1992 to that in 1995?
Offer a very short reply. 1.05. What is the ratio of the Female students (as % of total students) of Guam in 1992 to that in 1995?
Your answer should be compact. 0.99. What is the ratio of the Female students (as % of total students) of Romania in 1992 to that in 1995?
Offer a very short reply. 1.02. What is the difference between the highest and the second highest Female students (as % of total students) of Cameroon?
Keep it short and to the point. 1.52. What is the difference between the highest and the second highest Female students (as % of total students) in Guam?
Give a very brief answer. 0.28. What is the difference between the highest and the second highest Female students (as % of total students) of Papua New Guinea?
Offer a very short reply. 0.32. What is the difference between the highest and the second highest Female students (as % of total students) in Romania?
Provide a short and direct response. 0.55. What is the difference between the highest and the lowest Female students (as % of total students) in Cameroon?
Offer a terse response. 3.65. What is the difference between the highest and the lowest Female students (as % of total students) of Guam?
Provide a short and direct response. 1.67. What is the difference between the highest and the lowest Female students (as % of total students) of Papua New Guinea?
Offer a terse response. 9.42. What is the difference between the highest and the lowest Female students (as % of total students) of Romania?
Offer a very short reply. 2.62. 